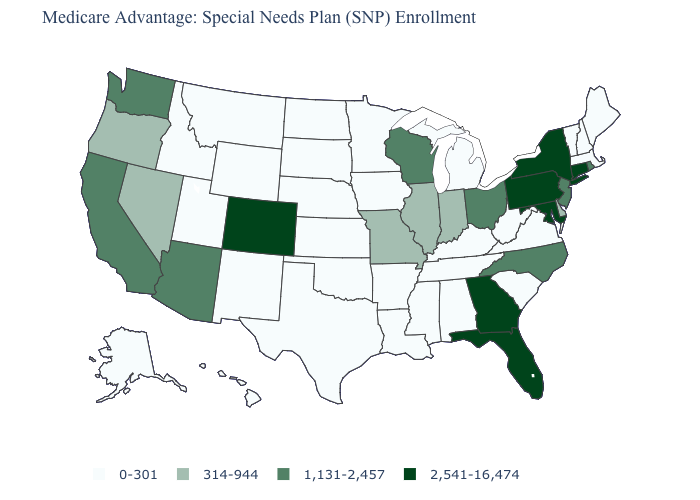Which states have the lowest value in the USA?
Keep it brief. Alaska, Alabama, Arkansas, Hawaii, Iowa, Idaho, Kansas, Kentucky, Louisiana, Massachusetts, Maine, Michigan, Minnesota, Mississippi, Montana, North Dakota, Nebraska, New Hampshire, New Mexico, Oklahoma, South Carolina, South Dakota, Tennessee, Texas, Utah, Virginia, Vermont, West Virginia, Wyoming. Name the states that have a value in the range 0-301?
Concise answer only. Alaska, Alabama, Arkansas, Hawaii, Iowa, Idaho, Kansas, Kentucky, Louisiana, Massachusetts, Maine, Michigan, Minnesota, Mississippi, Montana, North Dakota, Nebraska, New Hampshire, New Mexico, Oklahoma, South Carolina, South Dakota, Tennessee, Texas, Utah, Virginia, Vermont, West Virginia, Wyoming. What is the value of South Dakota?
Be succinct. 0-301. What is the value of Florida?
Keep it brief. 2,541-16,474. What is the value of New Mexico?
Write a very short answer. 0-301. Which states have the lowest value in the Northeast?
Write a very short answer. Massachusetts, Maine, New Hampshire, Vermont. What is the lowest value in states that border Utah?
Short answer required. 0-301. What is the highest value in states that border Nebraska?
Quick response, please. 2,541-16,474. Name the states that have a value in the range 1,131-2,457?
Quick response, please. Arizona, California, North Carolina, New Jersey, Ohio, Rhode Island, Washington, Wisconsin. What is the highest value in states that border Utah?
Short answer required. 2,541-16,474. What is the lowest value in the South?
Quick response, please. 0-301. Among the states that border West Virginia , which have the lowest value?
Write a very short answer. Kentucky, Virginia. Name the states that have a value in the range 1,131-2,457?
Give a very brief answer. Arizona, California, North Carolina, New Jersey, Ohio, Rhode Island, Washington, Wisconsin. What is the value of Illinois?
Answer briefly. 314-944. 